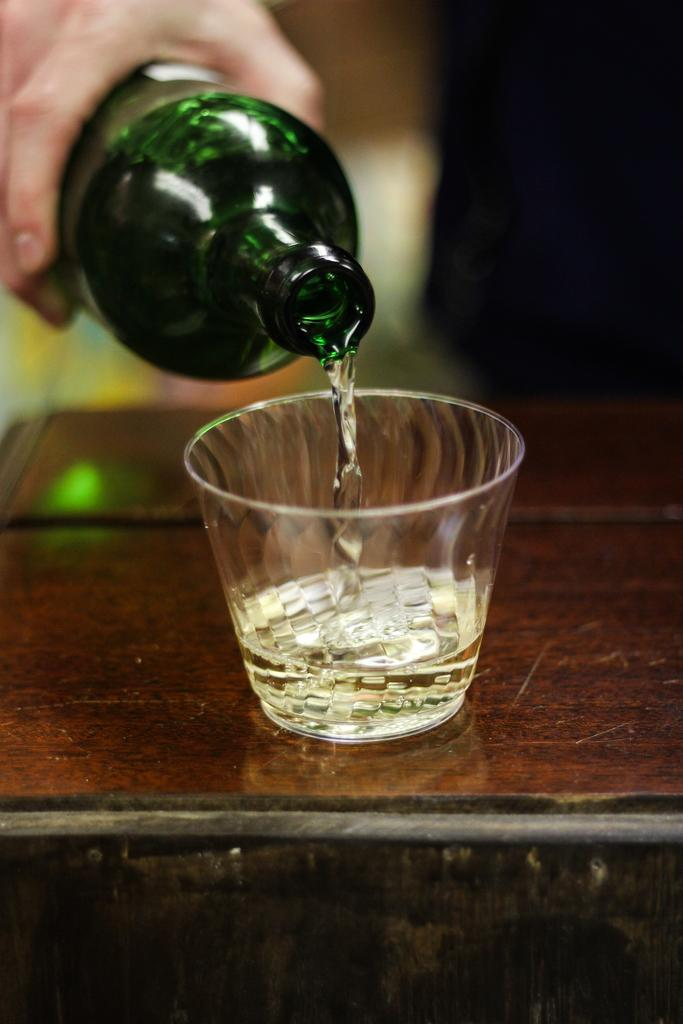What is the main object in the center of the image? There is a table in the middle of the image. What can be found on the table? There is a glass on the table. Where is the person holding a bottle located in the image? The person holding a bottle is in the top left side of the image. Can you see any fairies holding a locket near the flower in the image? There are no fairies, lockets, or flowers present in the image. 